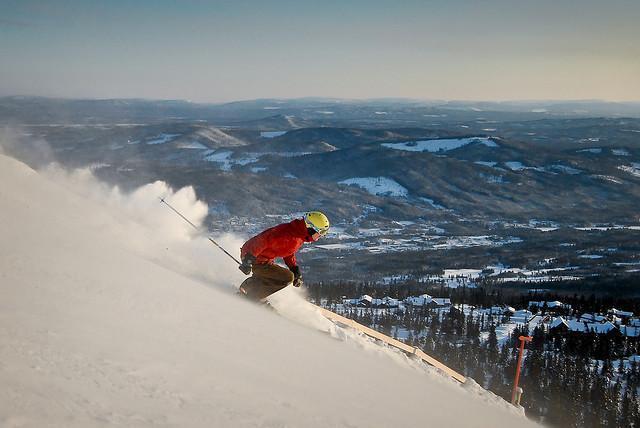How many toilets are white?
Give a very brief answer. 0. 